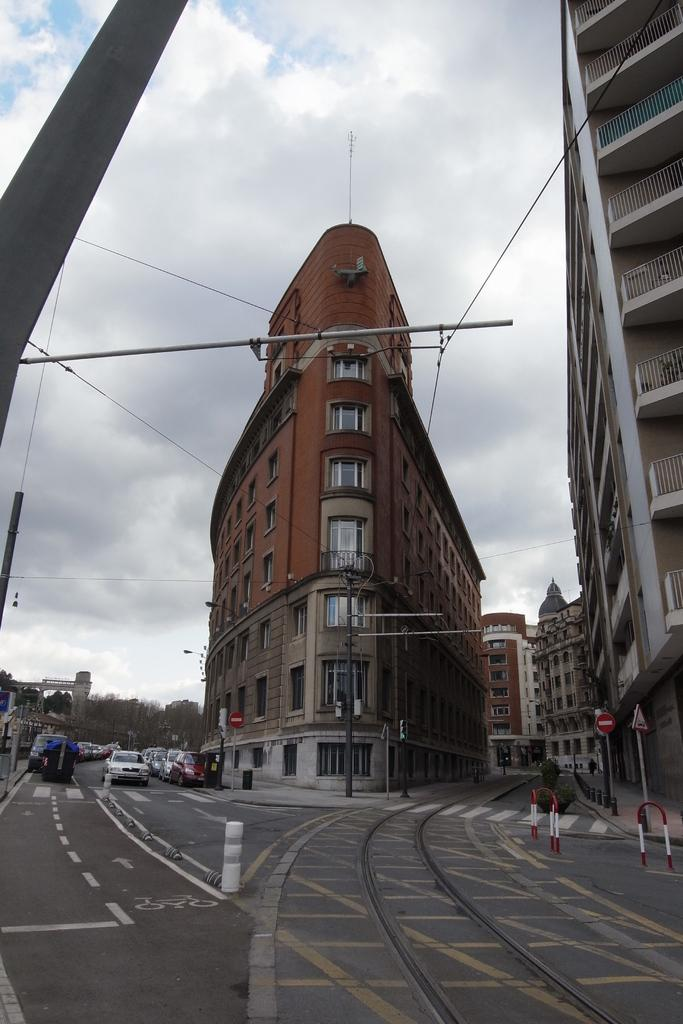What objects can be seen in the image that are long and thin? There are rods and poles in the image that are long and thin. What other objects can be seen in the image that are flat and rectangular? There are boards in the image that are flat and rectangular. What type of structures are visible in the image? There are buildings in the image. What type of infrastructure is present in the image? There are wires in the image. What type of transportation is visible in the image? There are vehicles on the road in the image. What type of natural elements can be seen in the background of the image? There are trees and sky visible in the background of the image. What type of weather can be inferred from the image? There are clouds in the sky, suggesting that it might be a partly cloudy day. Where is the yak grazing in the image? There is no yak present in the image. What type of fuel is being used by the vehicles in the image? The image does not provide information about the type of fuel being used by the vehicles. 